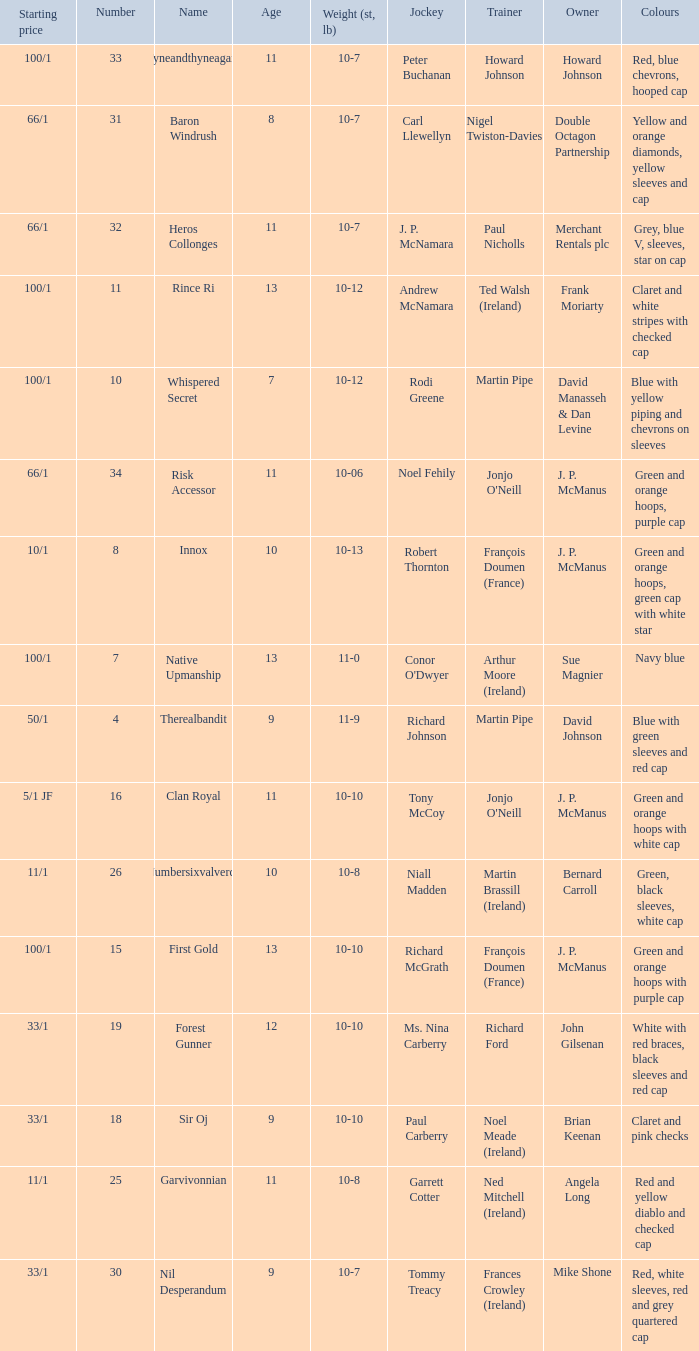What was the name of the entrant with an owner named David Johnson? Therealbandit. 